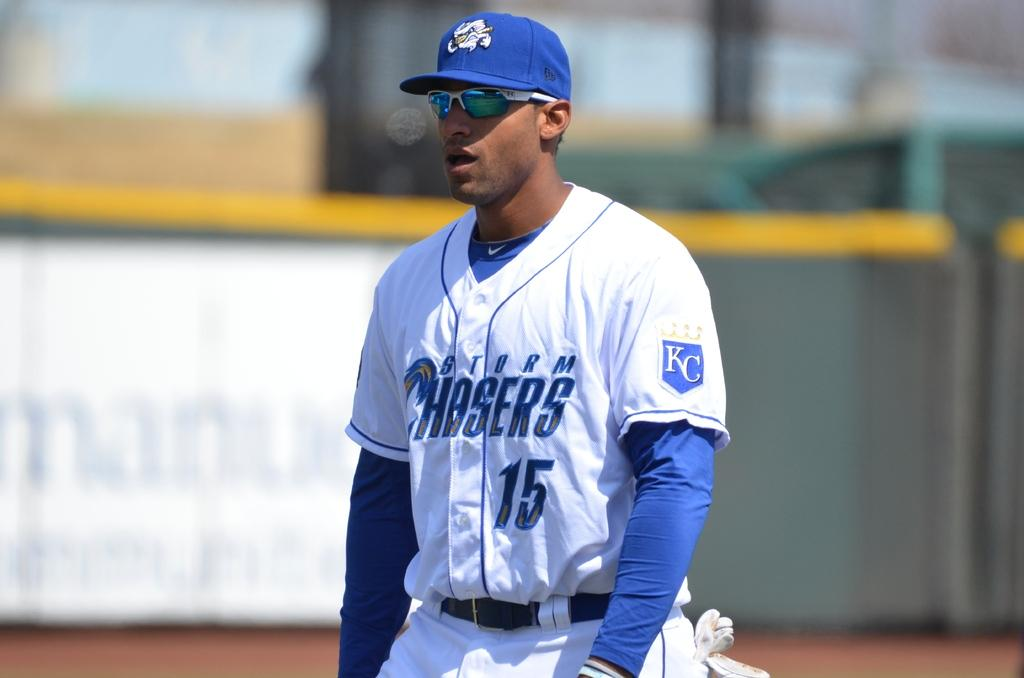Provide a one-sentence caption for the provided image. A baseball player from the KC Chasers is taking the field with his hat and sunglasses on a bright sunny day. 